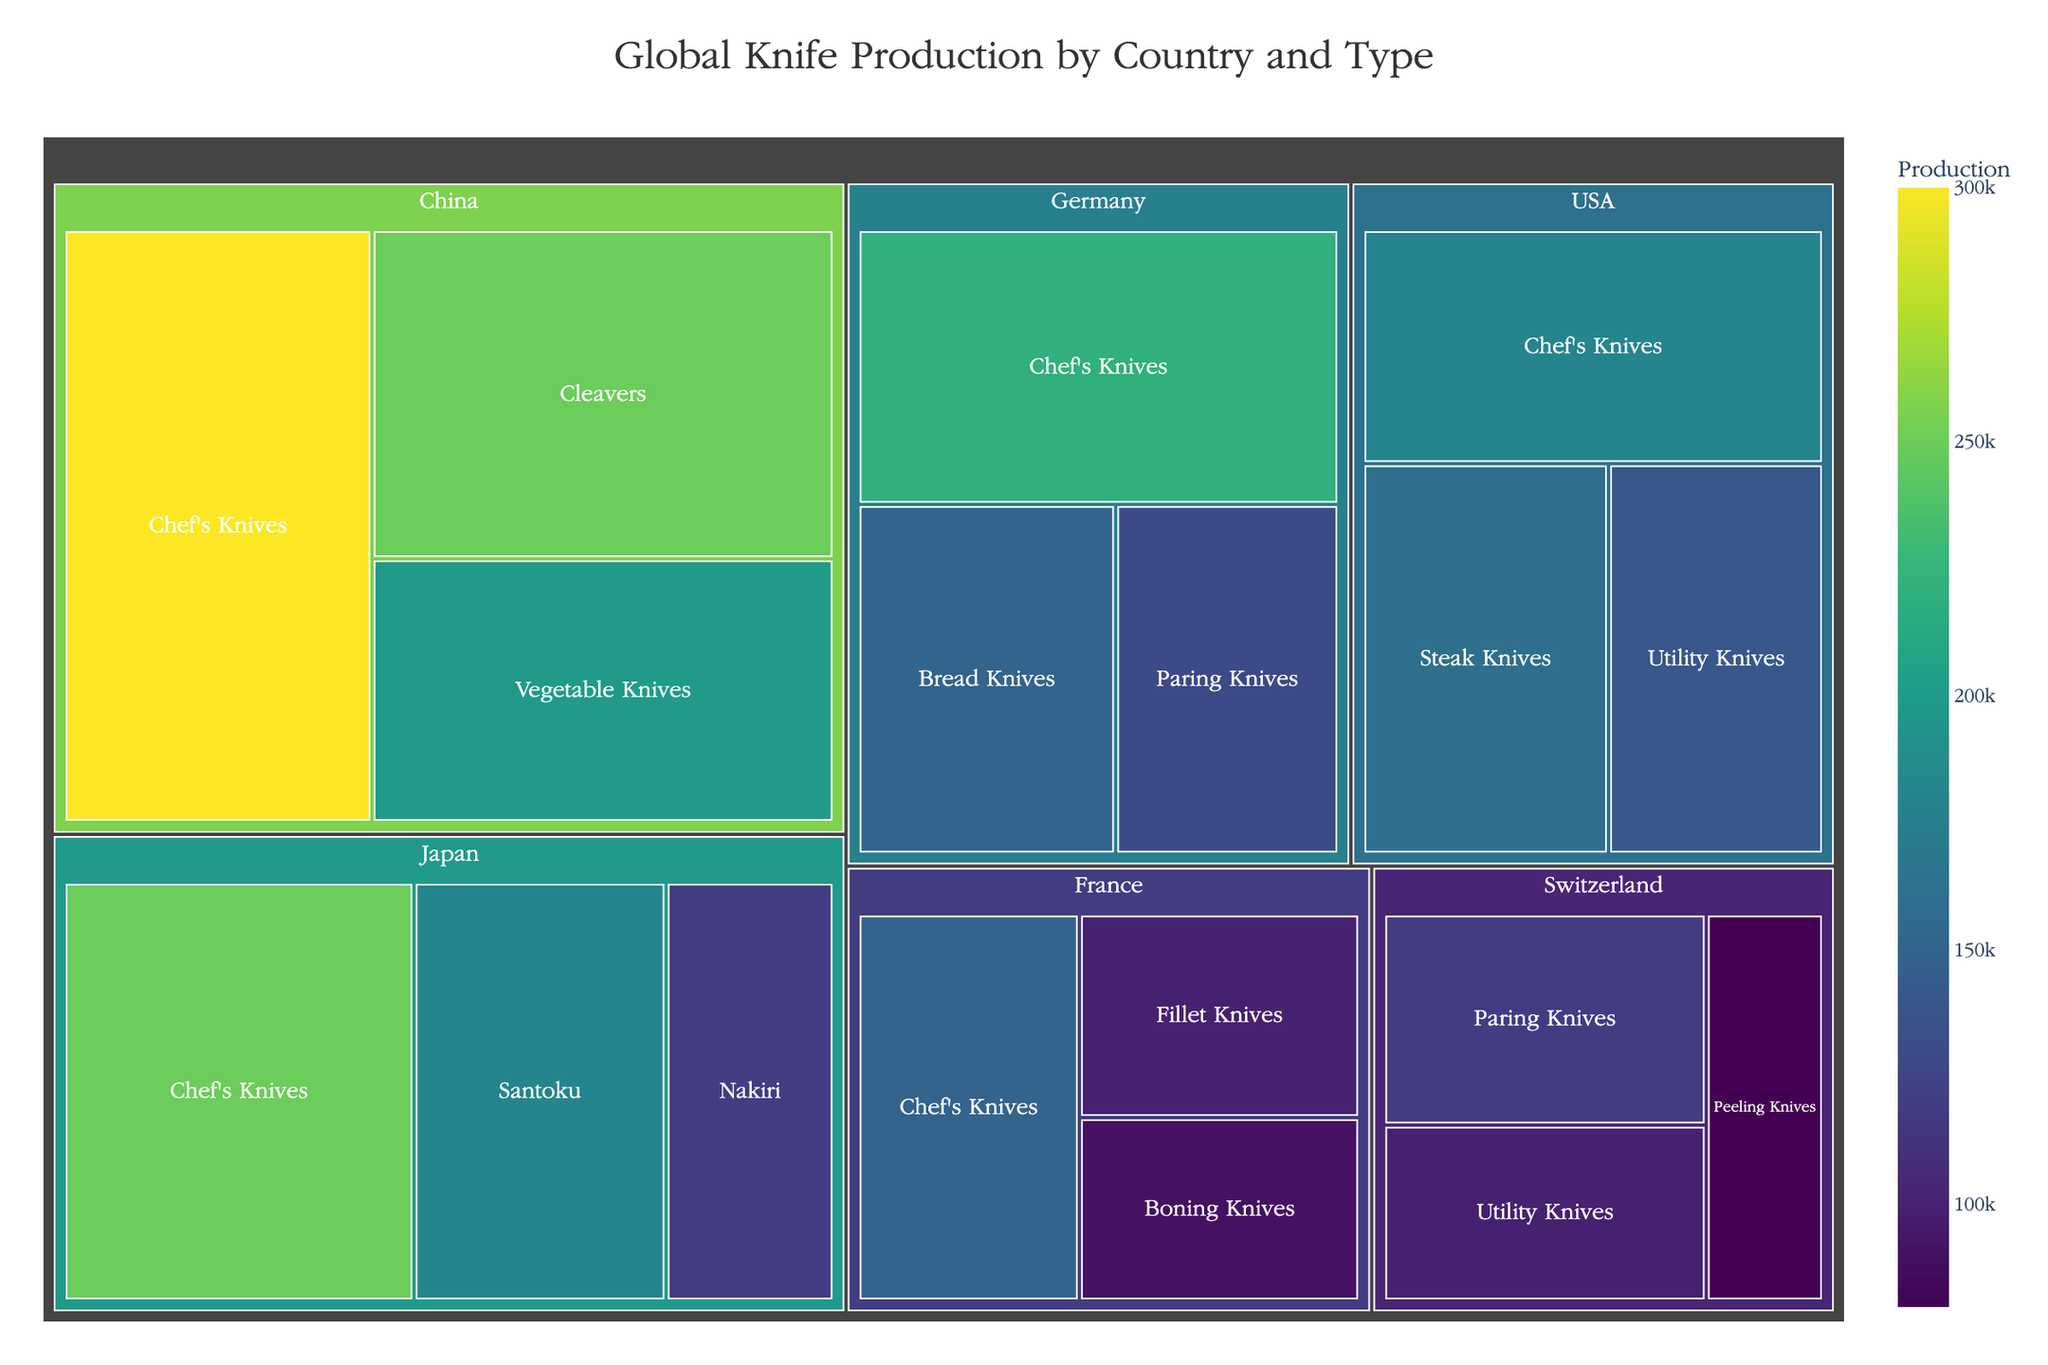What is the total production of Chef's Knives? To find the total production of Chef's Knives, add up the production values for Chef's Knives from each country: Japan (250,000), Germany (220,000), USA (180,000), France (150,000), China (300,000). Therefore, 250,000 + 220,000 + 180,000 + 150,000 + 300,000 = 1,100,000
Answer: 1,100,000 Which country has the highest production of Cleavers? From the treemap, locate the countries producing Cleavers. Only China produces Cleavers, with a production value of 250,000.
Answer: China How does the production of Paring Knives in Switzerland compare to Germany? Compare the production values: Switzerland produces 120,000 Paring Knives, while Germany produces 130,000 Paring Knives. Germany's production is slightly higher.
Answer: Germany Which knife type has the lowest total production across all countries? Calculate the total production for each knife type and find the lowest one:
- Chef's Knives: 1,100,000
- Santoku: 180,000
- Nakiri: 120,000
- Bread Knives: 150,000
- Paring Knives: 250,000 (Germany 130,000 + Switzerland 120,000)
- Steak Knives: 160,000
- Utility Knives: 240,000 (USA 140,000 + Switzerland 100,000)
- Fillet Knives: 100,000
- Boning Knives: 90,000
- Peeling Knives: 80,000
- Cleavers: 250,000
- Vegetable Knives: 200,000
The lowest total production is for Boning Knives at 90,000
Answer: Boning Knives What is the average production of knives in the USA? Calculate the average by summing the production values for knife types in the USA (180,000 for Chef's Knives, 160,000 for Steak Knives, 140,000 for Utility Knives) and then dividing by the number of types (3):
(180,000 + 160,000 + 140,000) / 3 = 480,000 / 3 = 160,000
Answer: 160,000 How much higher is China's Chef's Knives production compared to France's? Subtract France's Chef's Knives production from China's: 300,000 - 150,000 = 150,000
Answer: 150,000 Which country's section is colored the darkest shade, indicating the highest production? In the treemap, the darkest shade indicates the highest production. Locate the darkest section within the treemap, which corresponds to China, based on its highest production values.
Answer: China What is the cumulative production of all knife types in Germany? Add the production values for each knife type in Germany: 220,000 (Chef's Knives) + 150,000 (Bread Knives) + 130,000 (Paring Knives), resulting in: 220,000 + 150,000 + 130,000 = 500,000
Answer: 500,000 